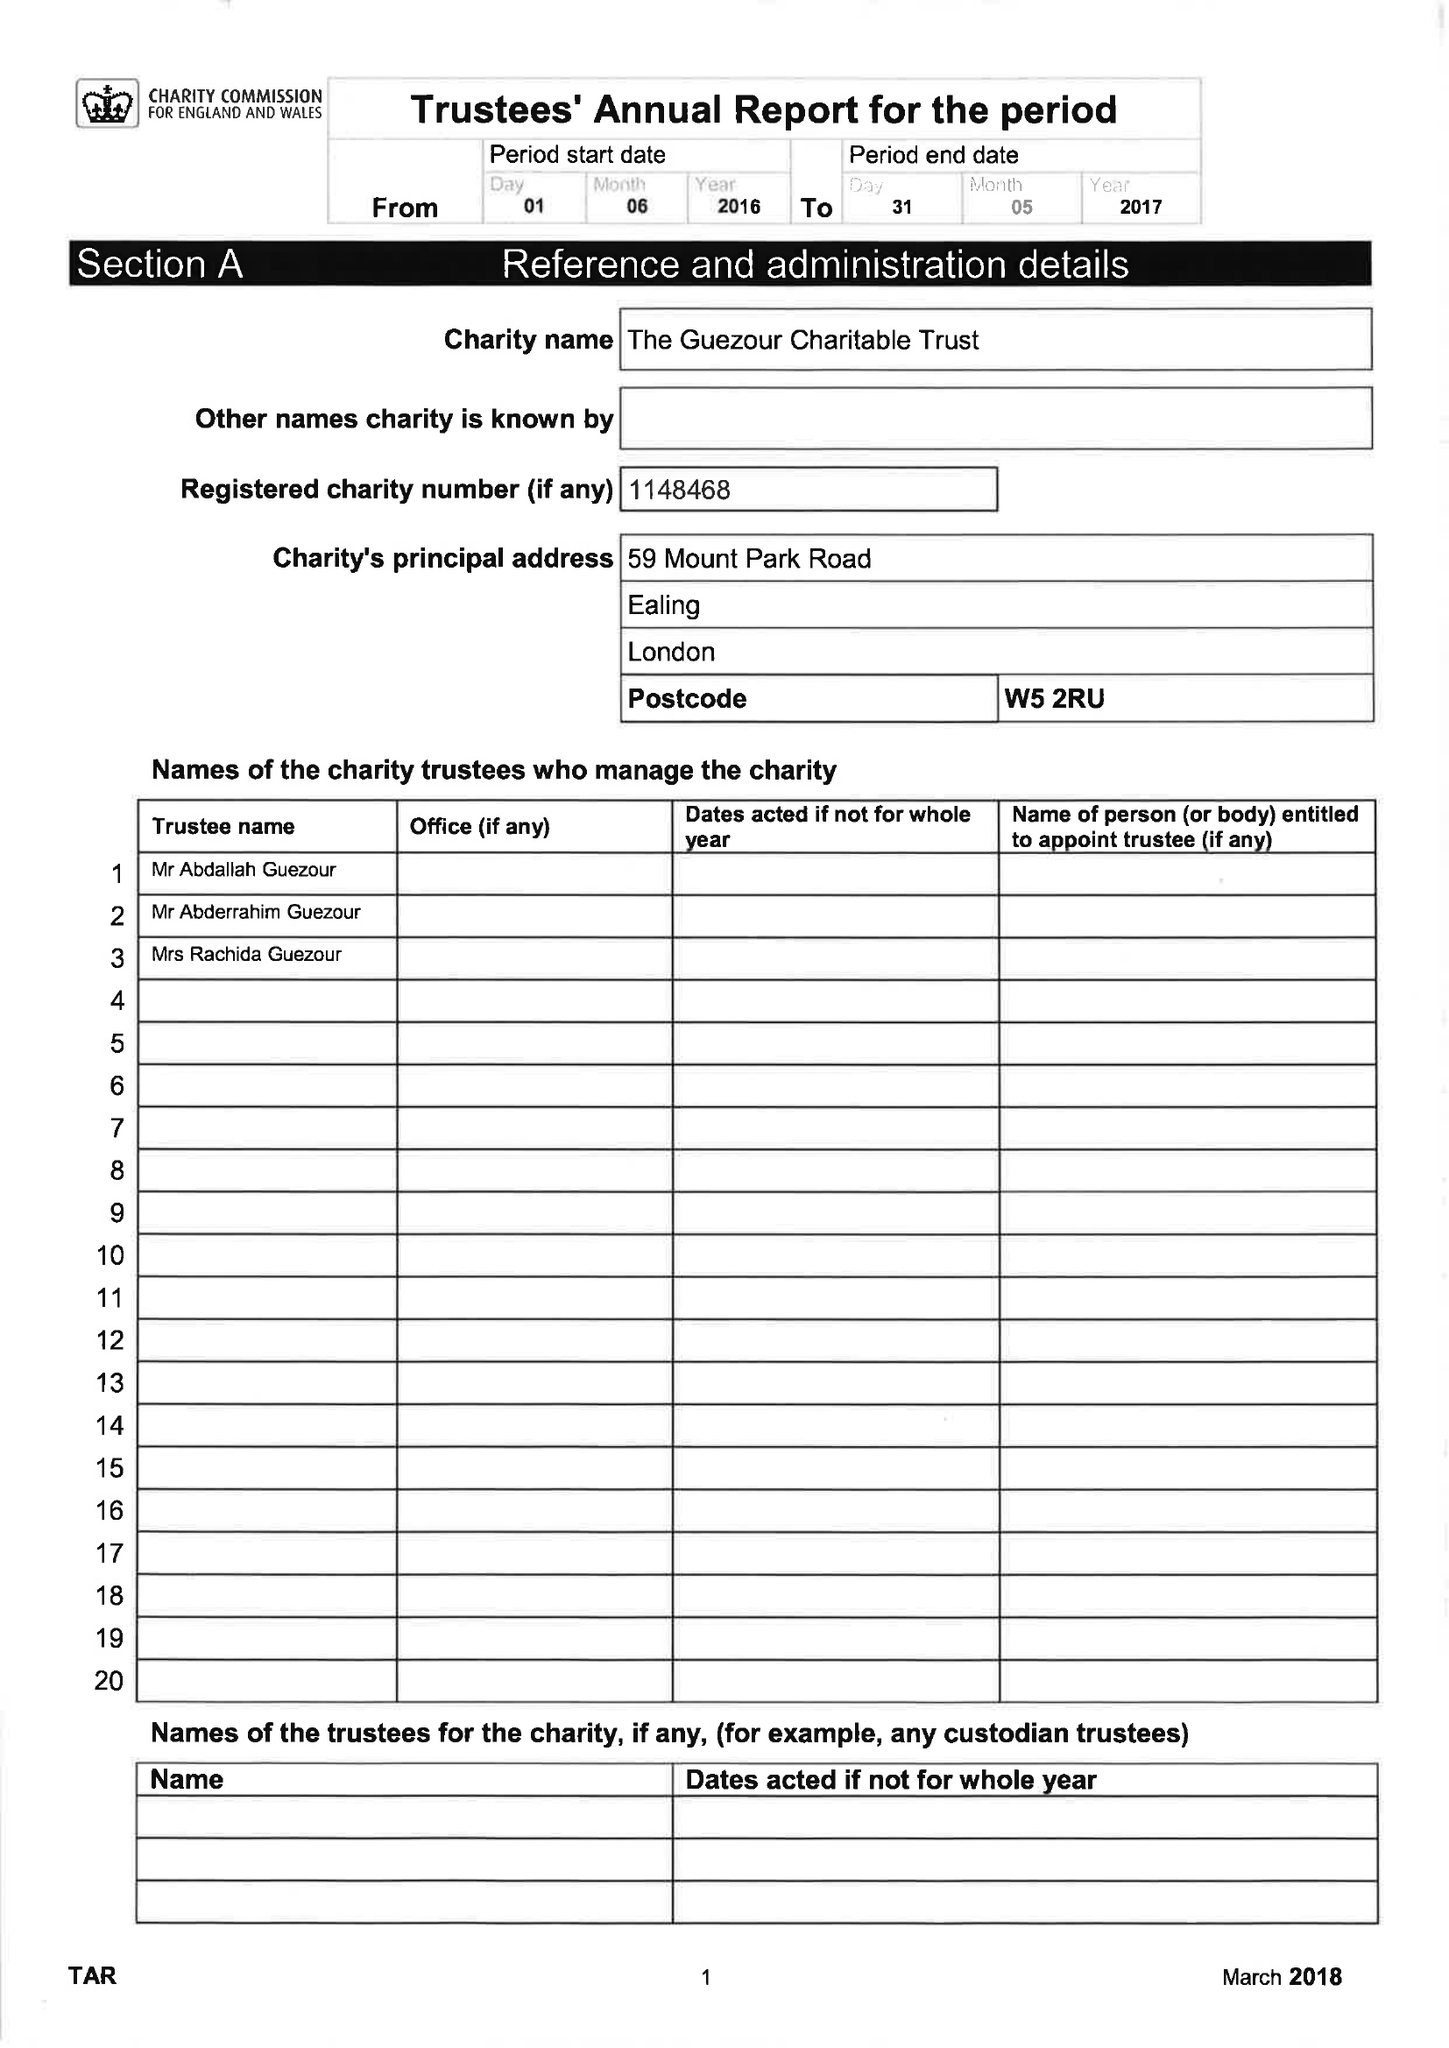What is the value for the report_date?
Answer the question using a single word or phrase. 2017-05-31 